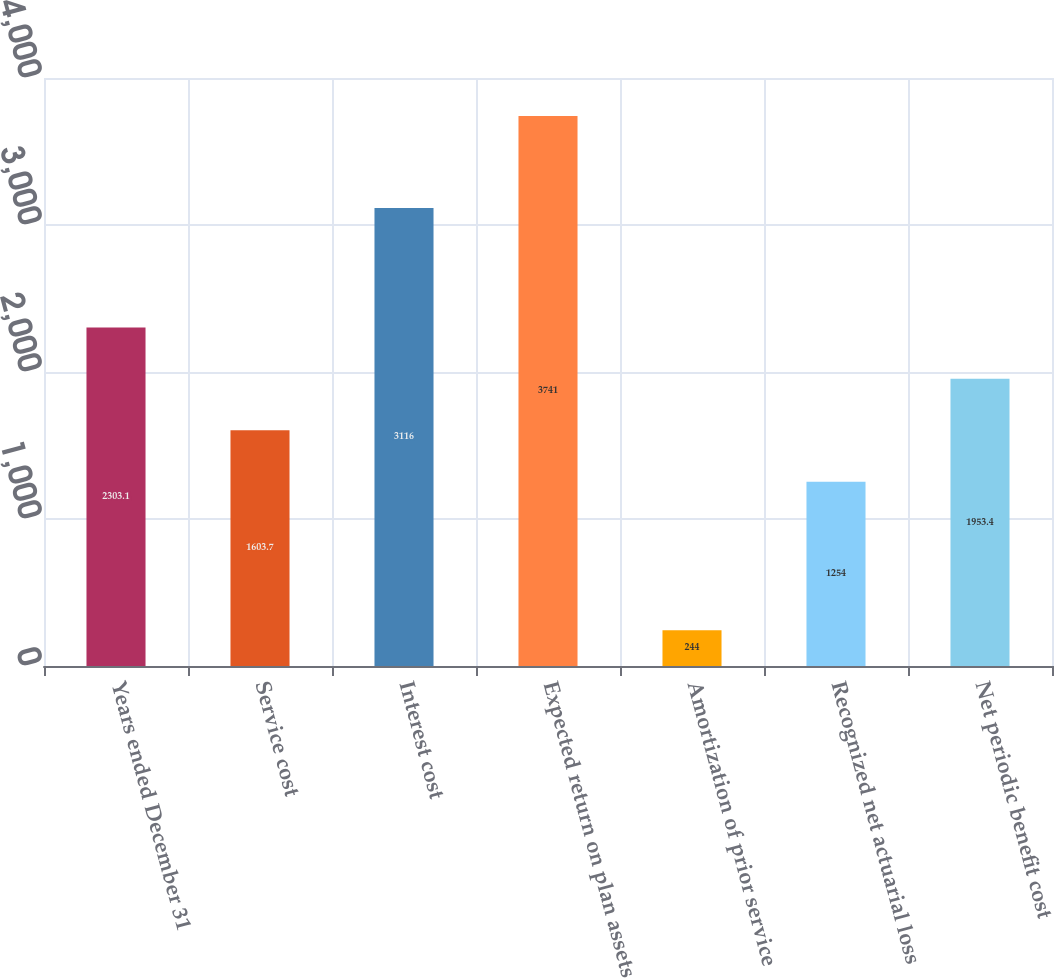Convert chart. <chart><loc_0><loc_0><loc_500><loc_500><bar_chart><fcel>Years ended December 31<fcel>Service cost<fcel>Interest cost<fcel>Expected return on plan assets<fcel>Amortization of prior service<fcel>Recognized net actuarial loss<fcel>Net periodic benefit cost<nl><fcel>2303.1<fcel>1603.7<fcel>3116<fcel>3741<fcel>244<fcel>1254<fcel>1953.4<nl></chart> 